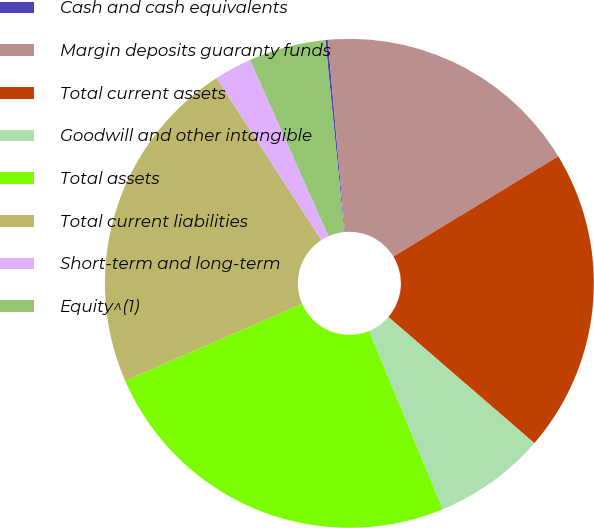Convert chart to OTSL. <chart><loc_0><loc_0><loc_500><loc_500><pie_chart><fcel>Cash and cash equivalents<fcel>Margin deposits guaranty funds<fcel>Total current assets<fcel>Goodwill and other intangible<fcel>Total assets<fcel>Total current liabilities<fcel>Short-term and long-term<fcel>Equity^(1)<nl><fcel>0.16%<fcel>17.71%<fcel>20.04%<fcel>7.42%<fcel>24.71%<fcel>22.38%<fcel>2.49%<fcel>5.09%<nl></chart> 